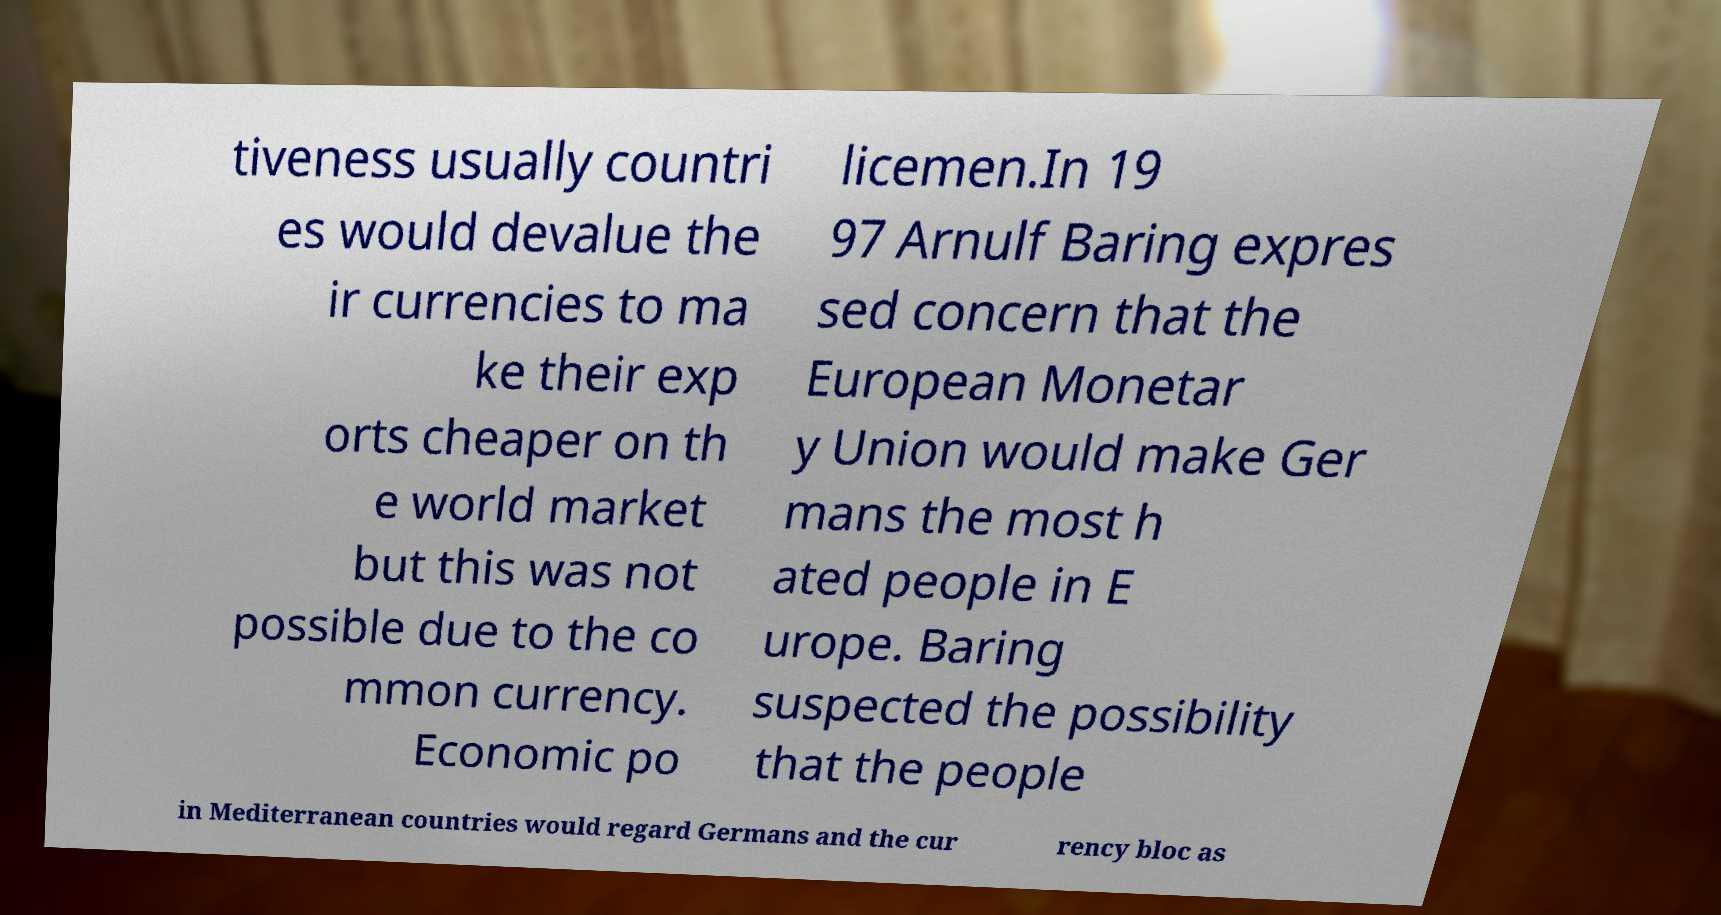Can you accurately transcribe the text from the provided image for me? tiveness usually countri es would devalue the ir currencies to ma ke their exp orts cheaper on th e world market but this was not possible due to the co mmon currency. Economic po licemen.In 19 97 Arnulf Baring expres sed concern that the European Monetar y Union would make Ger mans the most h ated people in E urope. Baring suspected the possibility that the people in Mediterranean countries would regard Germans and the cur rency bloc as 